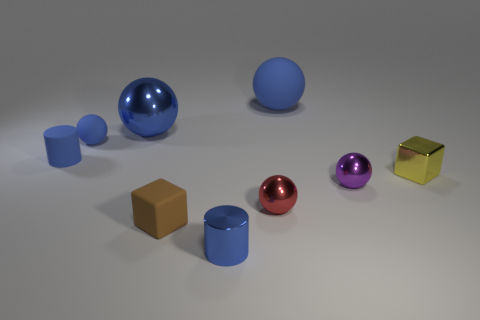How many blue spheres must be subtracted to get 1 blue spheres? 2 Subtract all green blocks. How many blue balls are left? 3 Add 1 big red metal spheres. How many objects exist? 10 Subtract all spheres. How many objects are left? 4 Subtract 1 purple spheres. How many objects are left? 8 Subtract all small blue metal objects. Subtract all small cubes. How many objects are left? 6 Add 4 brown rubber things. How many brown rubber things are left? 5 Add 7 purple metallic objects. How many purple metallic objects exist? 8 